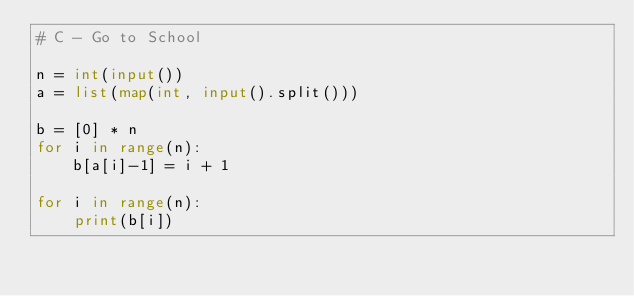<code> <loc_0><loc_0><loc_500><loc_500><_Python_># C - Go to School

n = int(input())
a = list(map(int, input().split()))

b = [0] * n
for i in range(n):
    b[a[i]-1] = i + 1

for i in range(n):
    print(b[i])
</code> 